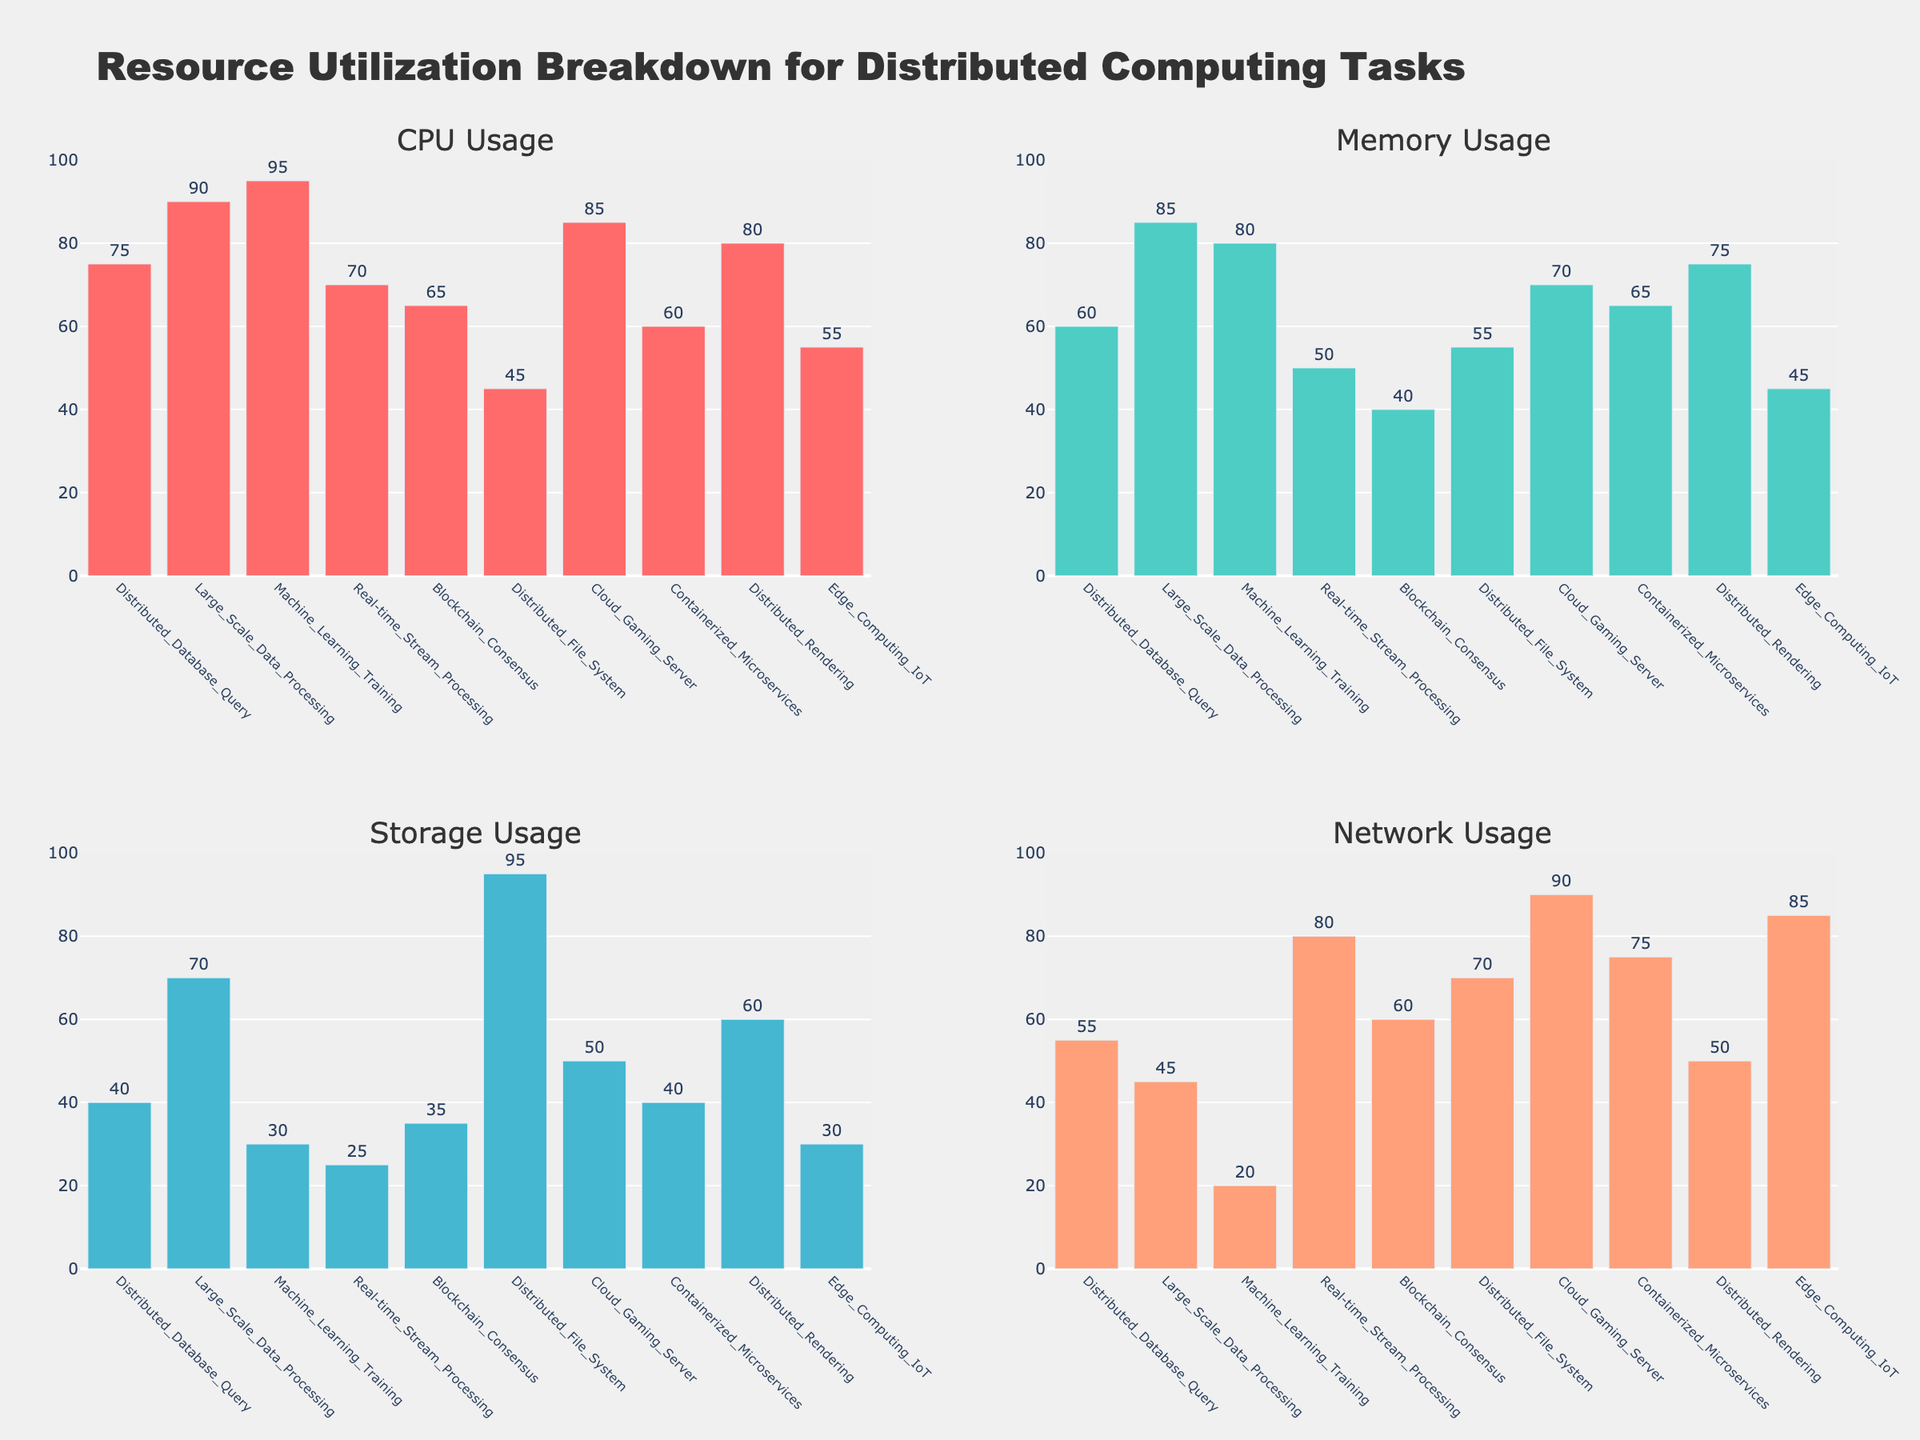Which computing task has the highest CPU usage? Look for the computing task with the highest bar in the CPU Usage subplot.
Answer: Machine_Learning_Training Which task has the lowest storage usage? Look for the shortest bar in the Storage Usage subplot.
Answer: Real-time_Stream_Processing What is the total memory usage for Distributed_Database_Query and Cloud_Gaming_Server? Add the memory usage values for both tasks: 60 + 70.
Answer: 130 Which task has a higher network usage: Blockchain_Consensus or Containerized_Microservices? Compare the bar heights for Network Usage between Blockchain_Consensus and Containerized_Microservices.
Answer: Blockchain_Consensus What's the average storage usage across all tasks? Sum all storage usage values and divide by the number of tasks: (40 + 70 + 30 + 25 + 35 + 95 + 50 + 40 + 60 + 30) / 10 = 47.5.
Answer: 47.5 How does memory usage for Distributed_Database_Query compare to that of Edge_Computing_IoT? Compare the memory usage bars of both tasks. Distributed_Database_Query has 60%, and Edge_Computing_IoT has 45%.
Answer: Higher Which task shows the most balanced resource utilization across all categories? Look for the task where the bars in all subplots are roughly similar in height.
Answer: Cloud_Gaming_Server What's the network usage difference between Real-time_Stream_Processing and Large_Scale_Data_Processing? Subtract the network usage of Large_Scale_Data_Processing from Real-time_Stream_Processing: 80 - 45.
Answer: 35 What is the storage usage for Distributed_File_System? Find the corresponding bar in the Storage Usage subplot.
Answer: 95 Which task has a higher CPU usage, Distributed_Rendering or Distributed_Database_Query? Compare the bar heights for CPU Usage between Distributed_Rendering and Distributed_Database_Query.
Answer: Distributed_Rendering 